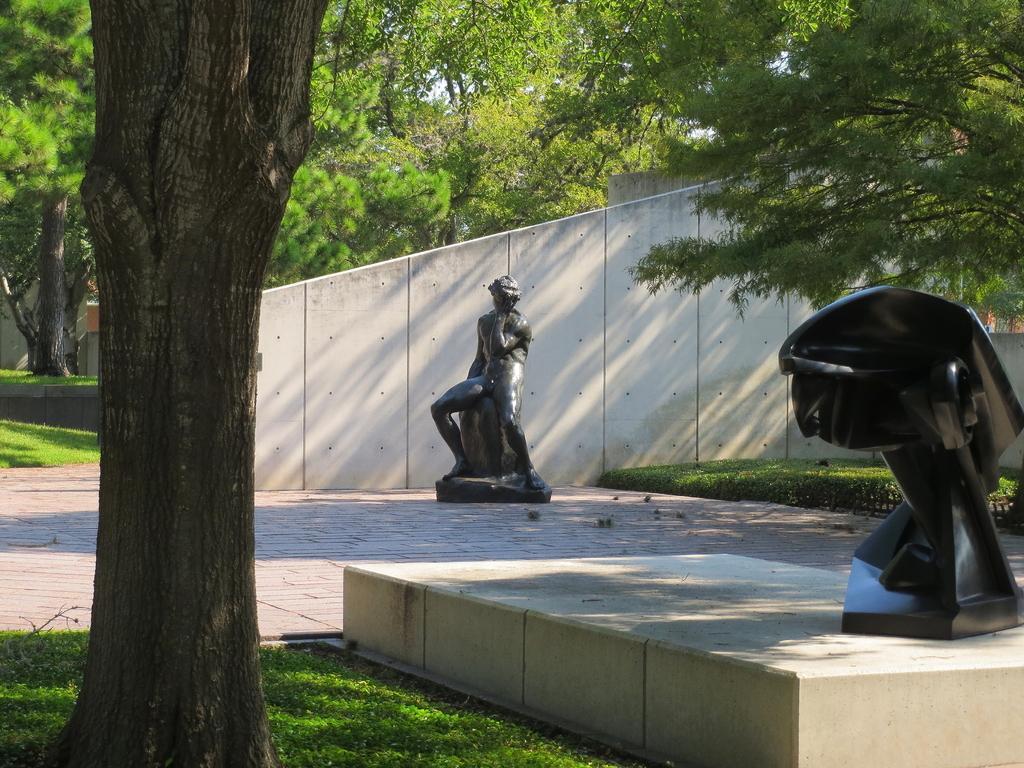How would you summarize this image in a sentence or two? In this image I can see two black color statues. I can see few trees and fencing. 